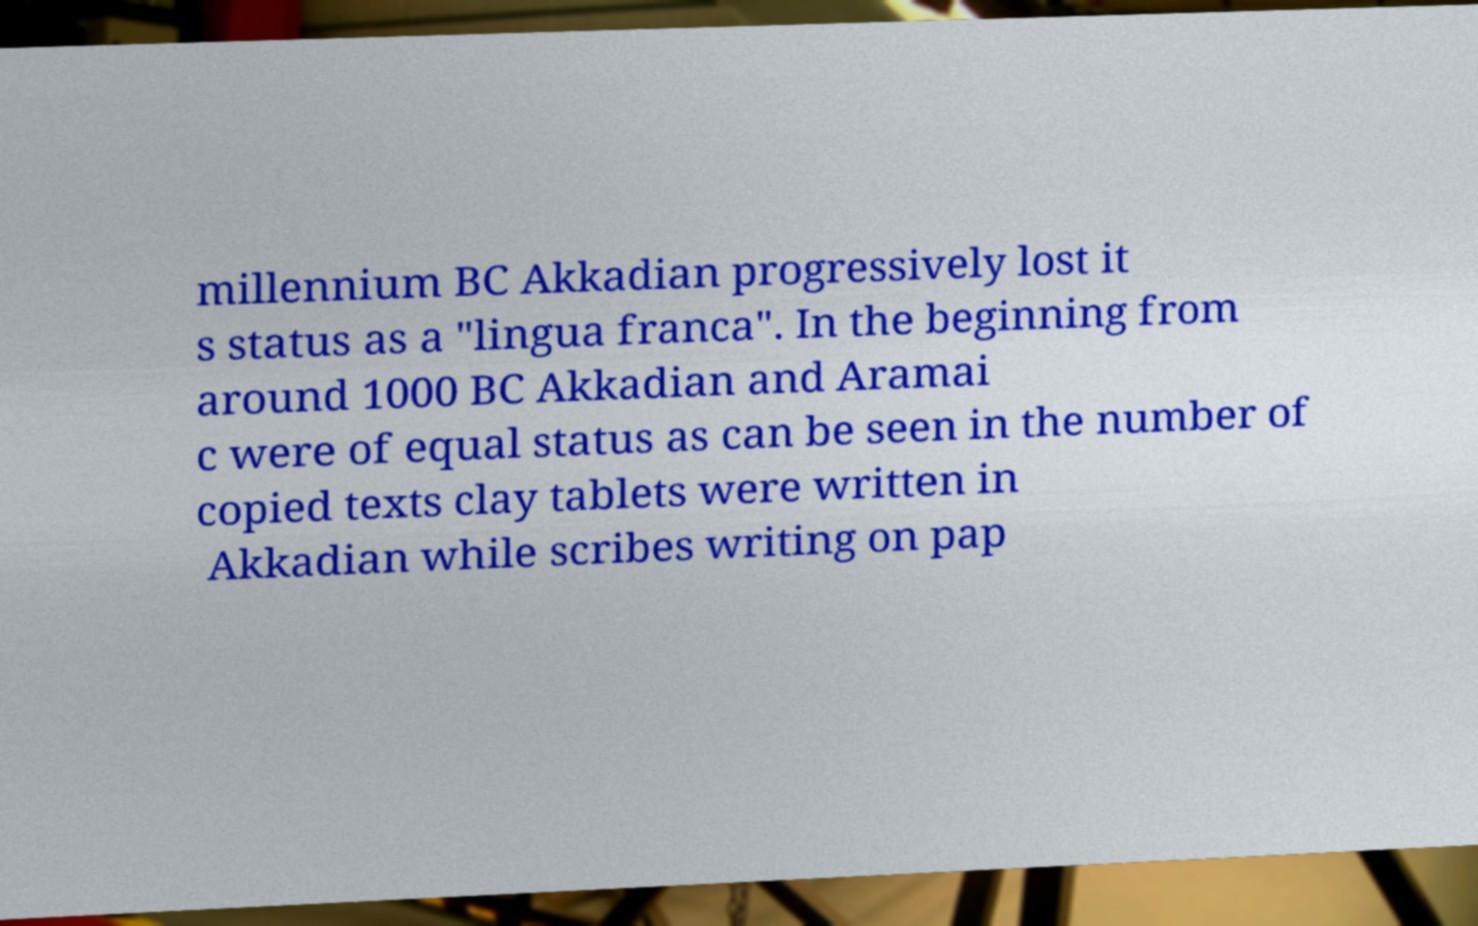Could you assist in decoding the text presented in this image and type it out clearly? millennium BC Akkadian progressively lost it s status as a "lingua franca". In the beginning from around 1000 BC Akkadian and Aramai c were of equal status as can be seen in the number of copied texts clay tablets were written in Akkadian while scribes writing on pap 